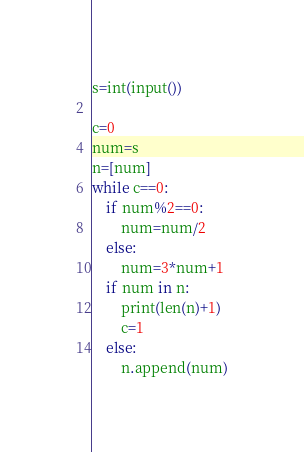Convert code to text. <code><loc_0><loc_0><loc_500><loc_500><_Python_>s=int(input())

c=0
num=s
n=[num]
while c==0:
    if num%2==0:
        num=num/2
    else:
        num=3*num+1
    if num in n:
        print(len(n)+1)
        c=1
    else:
        n.append(num)</code> 